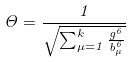Convert formula to latex. <formula><loc_0><loc_0><loc_500><loc_500>\Theta = \frac { 1 } { \sqrt { \sum _ { \mu = 1 } ^ { k } \frac { g ^ { 6 } } { b _ { \mu } ^ { 6 } } } }</formula> 